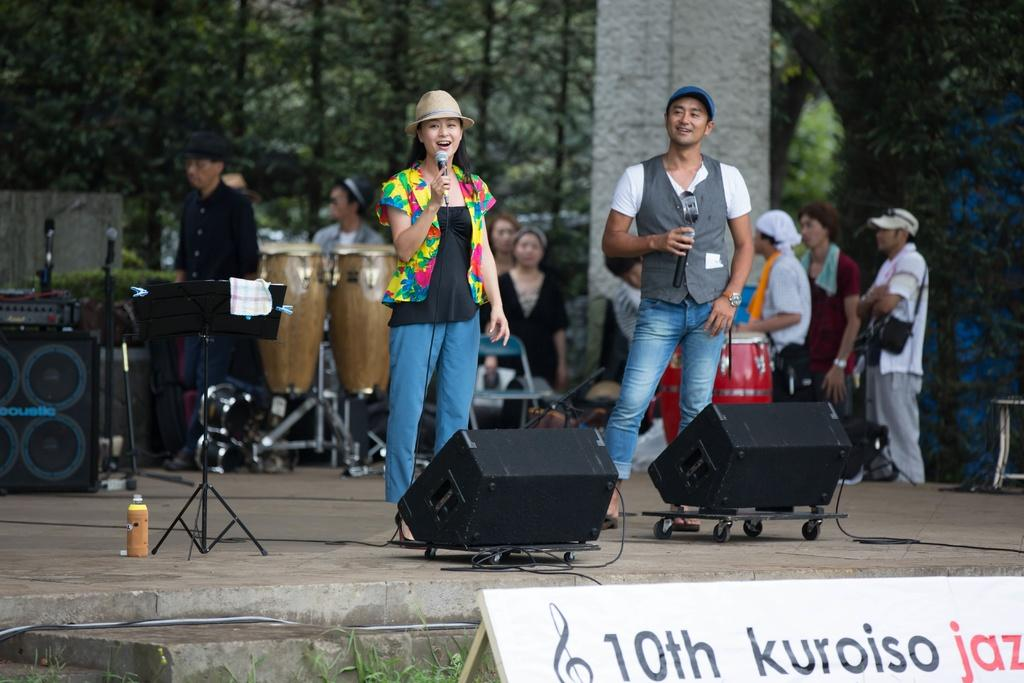What is the woman in the image holding? The woman is holding a microphone in her hand. What is the man in the image holding? The man is holding a microphone in his hand. Can you describe the people visible behind the woman and man? There are people visible behind the woman and man, but their specific actions or features cannot be determined from the provided facts. What type of slope can be seen in the image? There is no slope present in the image. How many trees are visible in the image? There is no tree visible in the image. 